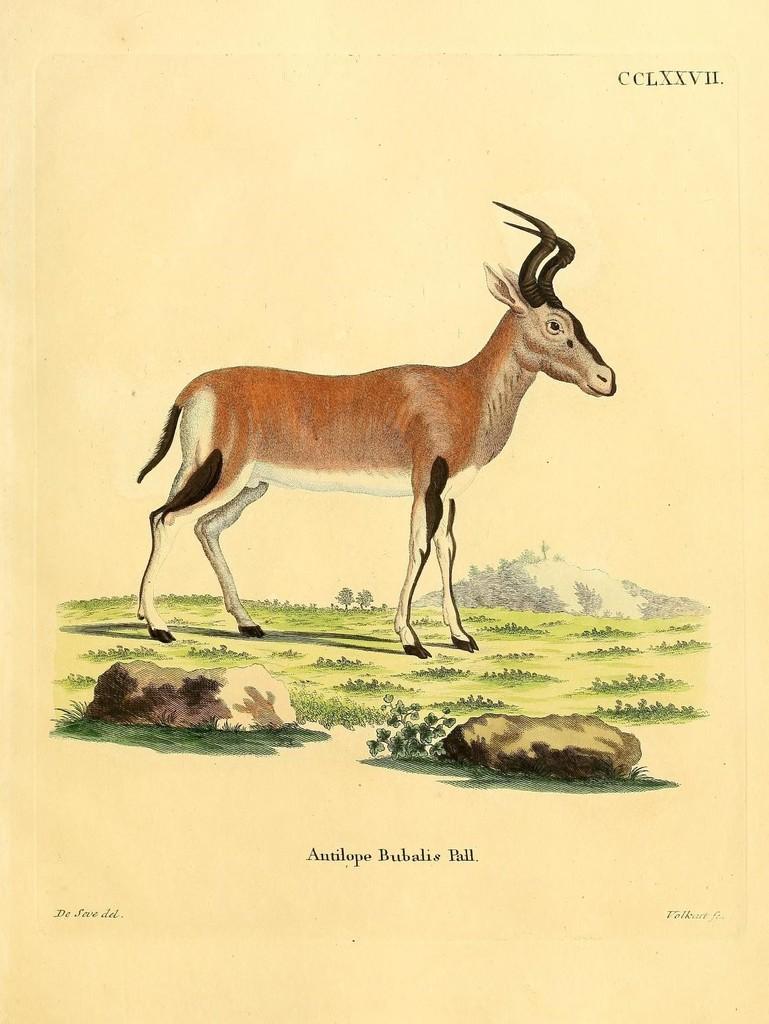Can you describe this image briefly? In this image there is a painting. An animal is standing on the land having grass and rocks. Behind there is a hill. Bottom of image that is some text. 